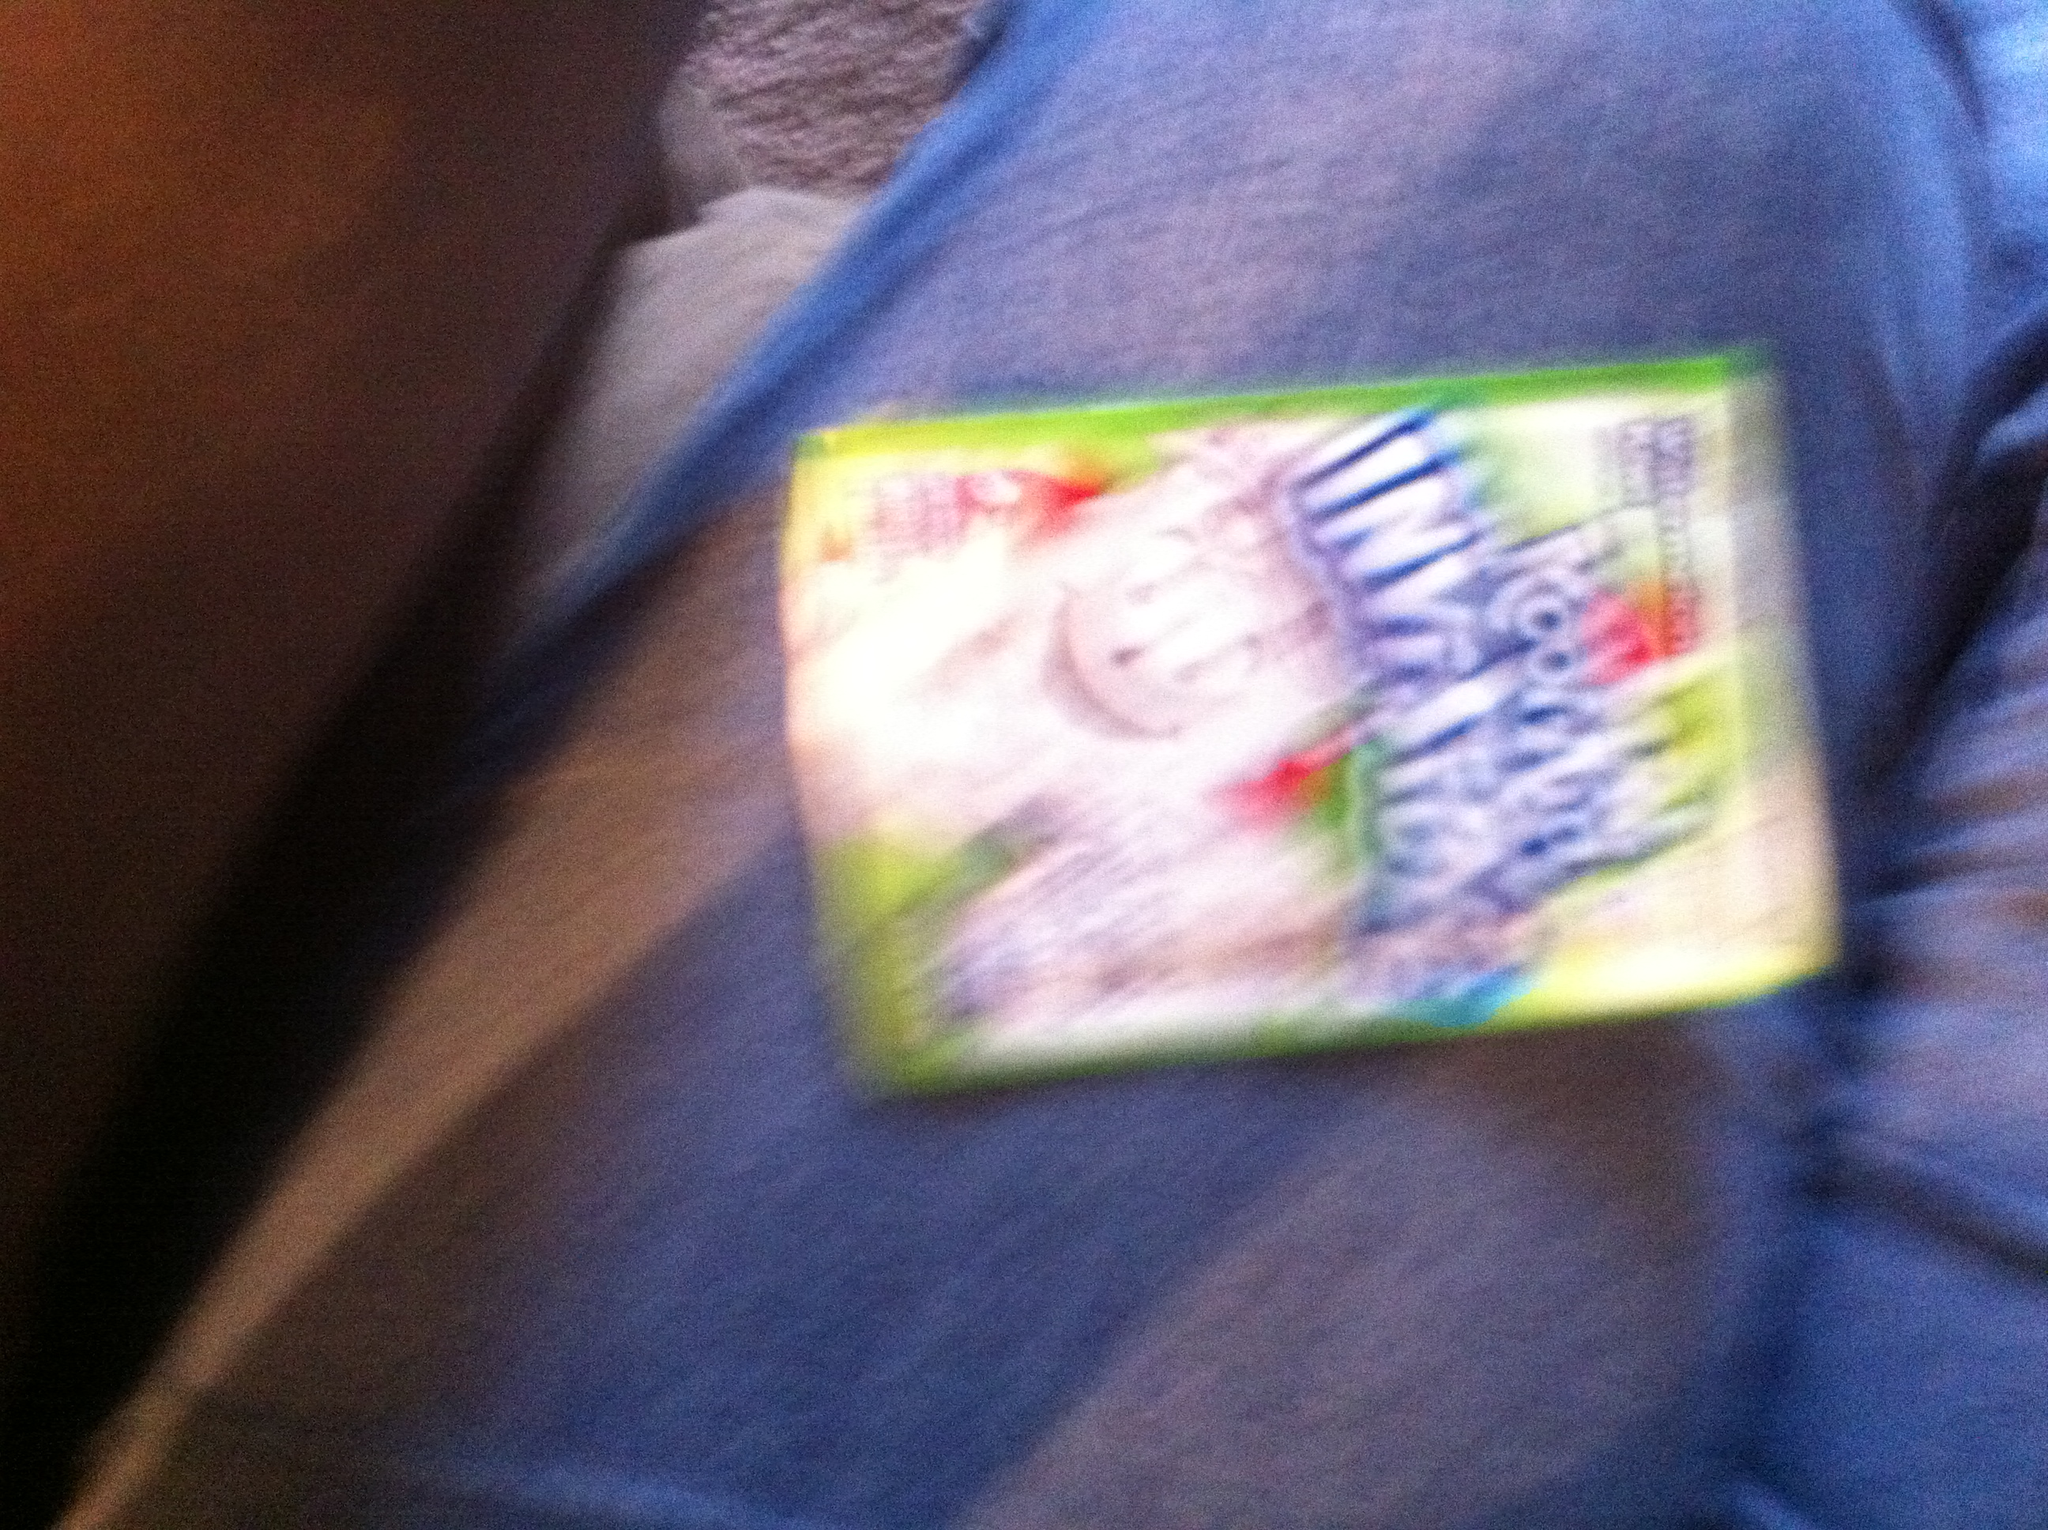Why would a brand choose to make a drink 'invisible'? Does it have any benefits? Brands often choose to make a 'invisible' drink for several reasons. Visually, the colorlessness can imply purity or a lack of artificial coloring, which might be perceived as healthier by some consumers. It can also be beneficial for parents who want to avoid the potential for stains on clothing or furniture from spills. Additionally, such products can spark conversations and draw attention purely through their uniqueness, acting as a talking point that can indirectly promote the brand. 